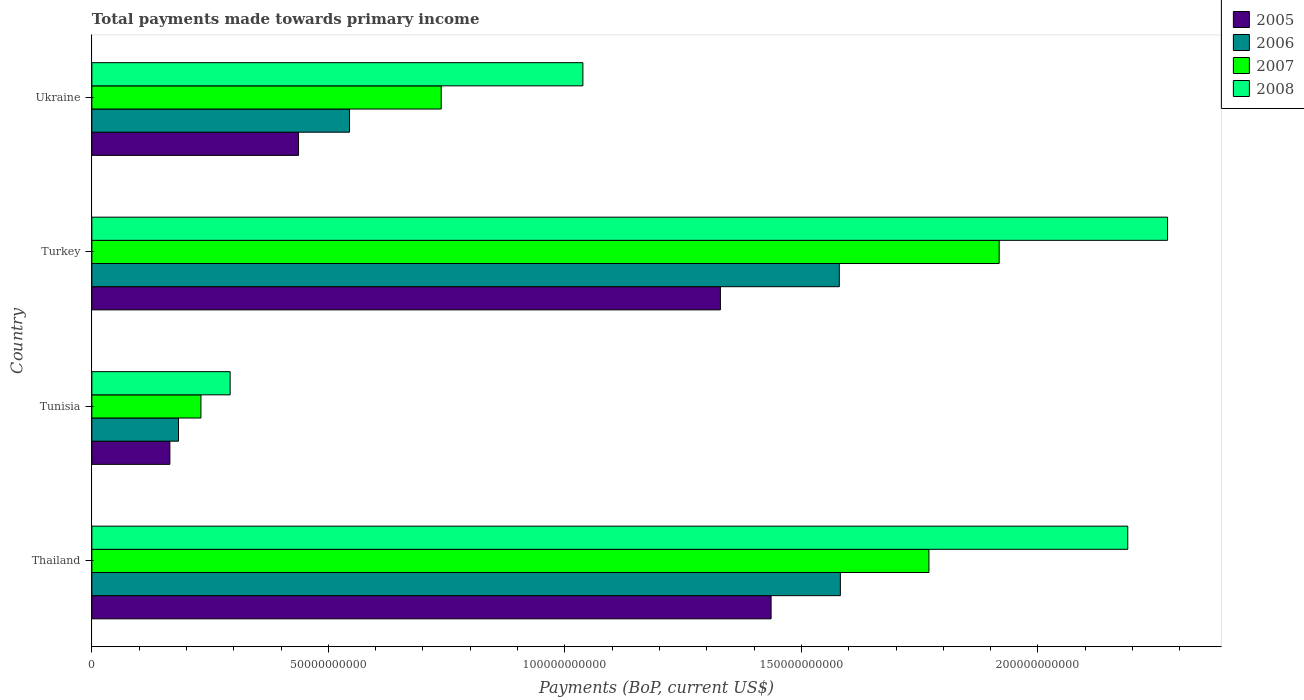How many different coloured bars are there?
Your response must be concise. 4. Are the number of bars on each tick of the Y-axis equal?
Your response must be concise. Yes. How many bars are there on the 2nd tick from the top?
Your response must be concise. 4. What is the label of the 4th group of bars from the top?
Your answer should be compact. Thailand. What is the total payments made towards primary income in 2005 in Turkey?
Provide a succinct answer. 1.33e+11. Across all countries, what is the maximum total payments made towards primary income in 2006?
Your answer should be very brief. 1.58e+11. Across all countries, what is the minimum total payments made towards primary income in 2007?
Give a very brief answer. 2.31e+1. In which country was the total payments made towards primary income in 2008 maximum?
Offer a very short reply. Turkey. In which country was the total payments made towards primary income in 2005 minimum?
Your answer should be compact. Tunisia. What is the total total payments made towards primary income in 2007 in the graph?
Your response must be concise. 4.66e+11. What is the difference between the total payments made towards primary income in 2006 in Tunisia and that in Turkey?
Provide a short and direct response. -1.40e+11. What is the difference between the total payments made towards primary income in 2008 in Ukraine and the total payments made towards primary income in 2006 in Thailand?
Give a very brief answer. -5.44e+1. What is the average total payments made towards primary income in 2005 per country?
Provide a short and direct response. 8.42e+1. What is the difference between the total payments made towards primary income in 2007 and total payments made towards primary income in 2006 in Ukraine?
Ensure brevity in your answer.  1.94e+1. In how many countries, is the total payments made towards primary income in 2006 greater than 110000000000 US$?
Make the answer very short. 2. What is the ratio of the total payments made towards primary income in 2006 in Thailand to that in Tunisia?
Offer a very short reply. 8.64. Is the total payments made towards primary income in 2008 in Tunisia less than that in Ukraine?
Offer a very short reply. Yes. What is the difference between the highest and the second highest total payments made towards primary income in 2007?
Make the answer very short. 1.48e+1. What is the difference between the highest and the lowest total payments made towards primary income in 2008?
Provide a succinct answer. 1.98e+11. In how many countries, is the total payments made towards primary income in 2008 greater than the average total payments made towards primary income in 2008 taken over all countries?
Provide a short and direct response. 2. Is it the case that in every country, the sum of the total payments made towards primary income in 2006 and total payments made towards primary income in 2005 is greater than the sum of total payments made towards primary income in 2007 and total payments made towards primary income in 2008?
Ensure brevity in your answer.  No. What does the 3rd bar from the top in Thailand represents?
Give a very brief answer. 2006. Is it the case that in every country, the sum of the total payments made towards primary income in 2007 and total payments made towards primary income in 2005 is greater than the total payments made towards primary income in 2006?
Make the answer very short. Yes. How many countries are there in the graph?
Provide a succinct answer. 4. Are the values on the major ticks of X-axis written in scientific E-notation?
Ensure brevity in your answer.  No. Does the graph contain any zero values?
Keep it short and to the point. No. How many legend labels are there?
Your answer should be compact. 4. How are the legend labels stacked?
Keep it short and to the point. Vertical. What is the title of the graph?
Offer a terse response. Total payments made towards primary income. What is the label or title of the X-axis?
Your answer should be very brief. Payments (BoP, current US$). What is the Payments (BoP, current US$) in 2005 in Thailand?
Offer a very short reply. 1.44e+11. What is the Payments (BoP, current US$) in 2006 in Thailand?
Offer a very short reply. 1.58e+11. What is the Payments (BoP, current US$) in 2007 in Thailand?
Give a very brief answer. 1.77e+11. What is the Payments (BoP, current US$) of 2008 in Thailand?
Keep it short and to the point. 2.19e+11. What is the Payments (BoP, current US$) of 2005 in Tunisia?
Keep it short and to the point. 1.65e+1. What is the Payments (BoP, current US$) of 2006 in Tunisia?
Ensure brevity in your answer.  1.83e+1. What is the Payments (BoP, current US$) of 2007 in Tunisia?
Keep it short and to the point. 2.31e+1. What is the Payments (BoP, current US$) in 2008 in Tunisia?
Provide a short and direct response. 2.92e+1. What is the Payments (BoP, current US$) of 2005 in Turkey?
Keep it short and to the point. 1.33e+11. What is the Payments (BoP, current US$) in 2006 in Turkey?
Your answer should be very brief. 1.58e+11. What is the Payments (BoP, current US$) of 2007 in Turkey?
Provide a short and direct response. 1.92e+11. What is the Payments (BoP, current US$) in 2008 in Turkey?
Provide a succinct answer. 2.27e+11. What is the Payments (BoP, current US$) in 2005 in Ukraine?
Provide a short and direct response. 4.37e+1. What is the Payments (BoP, current US$) in 2006 in Ukraine?
Provide a succinct answer. 5.45e+1. What is the Payments (BoP, current US$) of 2007 in Ukraine?
Your response must be concise. 7.39e+1. What is the Payments (BoP, current US$) of 2008 in Ukraine?
Your answer should be compact. 1.04e+11. Across all countries, what is the maximum Payments (BoP, current US$) in 2005?
Give a very brief answer. 1.44e+11. Across all countries, what is the maximum Payments (BoP, current US$) in 2006?
Your response must be concise. 1.58e+11. Across all countries, what is the maximum Payments (BoP, current US$) of 2007?
Provide a succinct answer. 1.92e+11. Across all countries, what is the maximum Payments (BoP, current US$) of 2008?
Provide a short and direct response. 2.27e+11. Across all countries, what is the minimum Payments (BoP, current US$) in 2005?
Make the answer very short. 1.65e+1. Across all countries, what is the minimum Payments (BoP, current US$) of 2006?
Keep it short and to the point. 1.83e+1. Across all countries, what is the minimum Payments (BoP, current US$) in 2007?
Give a very brief answer. 2.31e+1. Across all countries, what is the minimum Payments (BoP, current US$) of 2008?
Provide a succinct answer. 2.92e+1. What is the total Payments (BoP, current US$) in 2005 in the graph?
Make the answer very short. 3.37e+11. What is the total Payments (BoP, current US$) in 2006 in the graph?
Your answer should be very brief. 3.89e+11. What is the total Payments (BoP, current US$) of 2007 in the graph?
Your answer should be compact. 4.66e+11. What is the total Payments (BoP, current US$) in 2008 in the graph?
Your answer should be very brief. 5.79e+11. What is the difference between the Payments (BoP, current US$) of 2005 in Thailand and that in Tunisia?
Your response must be concise. 1.27e+11. What is the difference between the Payments (BoP, current US$) of 2006 in Thailand and that in Tunisia?
Keep it short and to the point. 1.40e+11. What is the difference between the Payments (BoP, current US$) in 2007 in Thailand and that in Tunisia?
Provide a short and direct response. 1.54e+11. What is the difference between the Payments (BoP, current US$) of 2008 in Thailand and that in Tunisia?
Make the answer very short. 1.90e+11. What is the difference between the Payments (BoP, current US$) in 2005 in Thailand and that in Turkey?
Offer a very short reply. 1.07e+1. What is the difference between the Payments (BoP, current US$) in 2006 in Thailand and that in Turkey?
Keep it short and to the point. 2.24e+08. What is the difference between the Payments (BoP, current US$) in 2007 in Thailand and that in Turkey?
Ensure brevity in your answer.  -1.48e+1. What is the difference between the Payments (BoP, current US$) in 2008 in Thailand and that in Turkey?
Your answer should be very brief. -8.42e+09. What is the difference between the Payments (BoP, current US$) in 2005 in Thailand and that in Ukraine?
Offer a very short reply. 9.99e+1. What is the difference between the Payments (BoP, current US$) in 2006 in Thailand and that in Ukraine?
Provide a short and direct response. 1.04e+11. What is the difference between the Payments (BoP, current US$) in 2007 in Thailand and that in Ukraine?
Give a very brief answer. 1.03e+11. What is the difference between the Payments (BoP, current US$) of 2008 in Thailand and that in Ukraine?
Make the answer very short. 1.15e+11. What is the difference between the Payments (BoP, current US$) in 2005 in Tunisia and that in Turkey?
Give a very brief answer. -1.16e+11. What is the difference between the Payments (BoP, current US$) in 2006 in Tunisia and that in Turkey?
Your answer should be compact. -1.40e+11. What is the difference between the Payments (BoP, current US$) in 2007 in Tunisia and that in Turkey?
Offer a very short reply. -1.69e+11. What is the difference between the Payments (BoP, current US$) of 2008 in Tunisia and that in Turkey?
Your response must be concise. -1.98e+11. What is the difference between the Payments (BoP, current US$) in 2005 in Tunisia and that in Ukraine?
Give a very brief answer. -2.72e+1. What is the difference between the Payments (BoP, current US$) of 2006 in Tunisia and that in Ukraine?
Offer a very short reply. -3.62e+1. What is the difference between the Payments (BoP, current US$) in 2007 in Tunisia and that in Ukraine?
Ensure brevity in your answer.  -5.08e+1. What is the difference between the Payments (BoP, current US$) of 2008 in Tunisia and that in Ukraine?
Make the answer very short. -7.46e+1. What is the difference between the Payments (BoP, current US$) of 2005 in Turkey and that in Ukraine?
Keep it short and to the point. 8.92e+1. What is the difference between the Payments (BoP, current US$) in 2006 in Turkey and that in Ukraine?
Make the answer very short. 1.04e+11. What is the difference between the Payments (BoP, current US$) of 2007 in Turkey and that in Ukraine?
Ensure brevity in your answer.  1.18e+11. What is the difference between the Payments (BoP, current US$) of 2008 in Turkey and that in Ukraine?
Make the answer very short. 1.24e+11. What is the difference between the Payments (BoP, current US$) of 2005 in Thailand and the Payments (BoP, current US$) of 2006 in Tunisia?
Your answer should be compact. 1.25e+11. What is the difference between the Payments (BoP, current US$) of 2005 in Thailand and the Payments (BoP, current US$) of 2007 in Tunisia?
Provide a succinct answer. 1.21e+11. What is the difference between the Payments (BoP, current US$) of 2005 in Thailand and the Payments (BoP, current US$) of 2008 in Tunisia?
Your answer should be very brief. 1.14e+11. What is the difference between the Payments (BoP, current US$) of 2006 in Thailand and the Payments (BoP, current US$) of 2007 in Tunisia?
Ensure brevity in your answer.  1.35e+11. What is the difference between the Payments (BoP, current US$) in 2006 in Thailand and the Payments (BoP, current US$) in 2008 in Tunisia?
Offer a terse response. 1.29e+11. What is the difference between the Payments (BoP, current US$) of 2007 in Thailand and the Payments (BoP, current US$) of 2008 in Tunisia?
Ensure brevity in your answer.  1.48e+11. What is the difference between the Payments (BoP, current US$) of 2005 in Thailand and the Payments (BoP, current US$) of 2006 in Turkey?
Keep it short and to the point. -1.44e+1. What is the difference between the Payments (BoP, current US$) in 2005 in Thailand and the Payments (BoP, current US$) in 2007 in Turkey?
Provide a succinct answer. -4.82e+1. What is the difference between the Payments (BoP, current US$) of 2005 in Thailand and the Payments (BoP, current US$) of 2008 in Turkey?
Your answer should be compact. -8.38e+1. What is the difference between the Payments (BoP, current US$) in 2006 in Thailand and the Payments (BoP, current US$) in 2007 in Turkey?
Keep it short and to the point. -3.36e+1. What is the difference between the Payments (BoP, current US$) in 2006 in Thailand and the Payments (BoP, current US$) in 2008 in Turkey?
Ensure brevity in your answer.  -6.92e+1. What is the difference between the Payments (BoP, current US$) in 2007 in Thailand and the Payments (BoP, current US$) in 2008 in Turkey?
Keep it short and to the point. -5.04e+1. What is the difference between the Payments (BoP, current US$) in 2005 in Thailand and the Payments (BoP, current US$) in 2006 in Ukraine?
Your answer should be very brief. 8.91e+1. What is the difference between the Payments (BoP, current US$) in 2005 in Thailand and the Payments (BoP, current US$) in 2007 in Ukraine?
Make the answer very short. 6.97e+1. What is the difference between the Payments (BoP, current US$) of 2005 in Thailand and the Payments (BoP, current US$) of 2008 in Ukraine?
Offer a terse response. 3.98e+1. What is the difference between the Payments (BoP, current US$) in 2006 in Thailand and the Payments (BoP, current US$) in 2007 in Ukraine?
Your answer should be compact. 8.44e+1. What is the difference between the Payments (BoP, current US$) in 2006 in Thailand and the Payments (BoP, current US$) in 2008 in Ukraine?
Offer a terse response. 5.44e+1. What is the difference between the Payments (BoP, current US$) of 2007 in Thailand and the Payments (BoP, current US$) of 2008 in Ukraine?
Keep it short and to the point. 7.32e+1. What is the difference between the Payments (BoP, current US$) of 2005 in Tunisia and the Payments (BoP, current US$) of 2006 in Turkey?
Your answer should be very brief. -1.42e+11. What is the difference between the Payments (BoP, current US$) of 2005 in Tunisia and the Payments (BoP, current US$) of 2007 in Turkey?
Offer a terse response. -1.75e+11. What is the difference between the Payments (BoP, current US$) in 2005 in Tunisia and the Payments (BoP, current US$) in 2008 in Turkey?
Offer a very short reply. -2.11e+11. What is the difference between the Payments (BoP, current US$) of 2006 in Tunisia and the Payments (BoP, current US$) of 2007 in Turkey?
Your response must be concise. -1.73e+11. What is the difference between the Payments (BoP, current US$) of 2006 in Tunisia and the Payments (BoP, current US$) of 2008 in Turkey?
Your answer should be compact. -2.09e+11. What is the difference between the Payments (BoP, current US$) of 2007 in Tunisia and the Payments (BoP, current US$) of 2008 in Turkey?
Keep it short and to the point. -2.04e+11. What is the difference between the Payments (BoP, current US$) in 2005 in Tunisia and the Payments (BoP, current US$) in 2006 in Ukraine?
Provide a short and direct response. -3.80e+1. What is the difference between the Payments (BoP, current US$) in 2005 in Tunisia and the Payments (BoP, current US$) in 2007 in Ukraine?
Your answer should be compact. -5.74e+1. What is the difference between the Payments (BoP, current US$) in 2005 in Tunisia and the Payments (BoP, current US$) in 2008 in Ukraine?
Provide a succinct answer. -8.73e+1. What is the difference between the Payments (BoP, current US$) in 2006 in Tunisia and the Payments (BoP, current US$) in 2007 in Ukraine?
Provide a short and direct response. -5.55e+1. What is the difference between the Payments (BoP, current US$) of 2006 in Tunisia and the Payments (BoP, current US$) of 2008 in Ukraine?
Ensure brevity in your answer.  -8.55e+1. What is the difference between the Payments (BoP, current US$) in 2007 in Tunisia and the Payments (BoP, current US$) in 2008 in Ukraine?
Offer a terse response. -8.07e+1. What is the difference between the Payments (BoP, current US$) of 2005 in Turkey and the Payments (BoP, current US$) of 2006 in Ukraine?
Give a very brief answer. 7.84e+1. What is the difference between the Payments (BoP, current US$) in 2005 in Turkey and the Payments (BoP, current US$) in 2007 in Ukraine?
Provide a succinct answer. 5.90e+1. What is the difference between the Payments (BoP, current US$) of 2005 in Turkey and the Payments (BoP, current US$) of 2008 in Ukraine?
Your answer should be compact. 2.91e+1. What is the difference between the Payments (BoP, current US$) in 2006 in Turkey and the Payments (BoP, current US$) in 2007 in Ukraine?
Give a very brief answer. 8.42e+1. What is the difference between the Payments (BoP, current US$) of 2006 in Turkey and the Payments (BoP, current US$) of 2008 in Ukraine?
Offer a terse response. 5.42e+1. What is the difference between the Payments (BoP, current US$) of 2007 in Turkey and the Payments (BoP, current US$) of 2008 in Ukraine?
Offer a very short reply. 8.80e+1. What is the average Payments (BoP, current US$) in 2005 per country?
Ensure brevity in your answer.  8.42e+1. What is the average Payments (BoP, current US$) of 2006 per country?
Provide a short and direct response. 9.73e+1. What is the average Payments (BoP, current US$) of 2007 per country?
Keep it short and to the point. 1.16e+11. What is the average Payments (BoP, current US$) in 2008 per country?
Offer a terse response. 1.45e+11. What is the difference between the Payments (BoP, current US$) in 2005 and Payments (BoP, current US$) in 2006 in Thailand?
Make the answer very short. -1.46e+1. What is the difference between the Payments (BoP, current US$) in 2005 and Payments (BoP, current US$) in 2007 in Thailand?
Your answer should be very brief. -3.34e+1. What is the difference between the Payments (BoP, current US$) of 2005 and Payments (BoP, current US$) of 2008 in Thailand?
Keep it short and to the point. -7.54e+1. What is the difference between the Payments (BoP, current US$) in 2006 and Payments (BoP, current US$) in 2007 in Thailand?
Offer a terse response. -1.87e+1. What is the difference between the Payments (BoP, current US$) of 2006 and Payments (BoP, current US$) of 2008 in Thailand?
Make the answer very short. -6.08e+1. What is the difference between the Payments (BoP, current US$) in 2007 and Payments (BoP, current US$) in 2008 in Thailand?
Your answer should be very brief. -4.20e+1. What is the difference between the Payments (BoP, current US$) in 2005 and Payments (BoP, current US$) in 2006 in Tunisia?
Provide a short and direct response. -1.82e+09. What is the difference between the Payments (BoP, current US$) of 2005 and Payments (BoP, current US$) of 2007 in Tunisia?
Provide a succinct answer. -6.57e+09. What is the difference between the Payments (BoP, current US$) in 2005 and Payments (BoP, current US$) in 2008 in Tunisia?
Your response must be concise. -1.27e+1. What is the difference between the Payments (BoP, current US$) of 2006 and Payments (BoP, current US$) of 2007 in Tunisia?
Your answer should be compact. -4.74e+09. What is the difference between the Payments (BoP, current US$) of 2006 and Payments (BoP, current US$) of 2008 in Tunisia?
Your answer should be compact. -1.09e+1. What is the difference between the Payments (BoP, current US$) in 2007 and Payments (BoP, current US$) in 2008 in Tunisia?
Provide a succinct answer. -6.17e+09. What is the difference between the Payments (BoP, current US$) in 2005 and Payments (BoP, current US$) in 2006 in Turkey?
Your answer should be compact. -2.51e+1. What is the difference between the Payments (BoP, current US$) in 2005 and Payments (BoP, current US$) in 2007 in Turkey?
Offer a terse response. -5.89e+1. What is the difference between the Payments (BoP, current US$) of 2005 and Payments (BoP, current US$) of 2008 in Turkey?
Offer a very short reply. -9.45e+1. What is the difference between the Payments (BoP, current US$) of 2006 and Payments (BoP, current US$) of 2007 in Turkey?
Ensure brevity in your answer.  -3.38e+1. What is the difference between the Payments (BoP, current US$) of 2006 and Payments (BoP, current US$) of 2008 in Turkey?
Give a very brief answer. -6.94e+1. What is the difference between the Payments (BoP, current US$) of 2007 and Payments (BoP, current US$) of 2008 in Turkey?
Give a very brief answer. -3.56e+1. What is the difference between the Payments (BoP, current US$) in 2005 and Payments (BoP, current US$) in 2006 in Ukraine?
Offer a very short reply. -1.08e+1. What is the difference between the Payments (BoP, current US$) in 2005 and Payments (BoP, current US$) in 2007 in Ukraine?
Provide a short and direct response. -3.02e+1. What is the difference between the Payments (BoP, current US$) in 2005 and Payments (BoP, current US$) in 2008 in Ukraine?
Offer a terse response. -6.01e+1. What is the difference between the Payments (BoP, current US$) of 2006 and Payments (BoP, current US$) of 2007 in Ukraine?
Provide a succinct answer. -1.94e+1. What is the difference between the Payments (BoP, current US$) in 2006 and Payments (BoP, current US$) in 2008 in Ukraine?
Offer a very short reply. -4.93e+1. What is the difference between the Payments (BoP, current US$) of 2007 and Payments (BoP, current US$) of 2008 in Ukraine?
Give a very brief answer. -2.99e+1. What is the ratio of the Payments (BoP, current US$) of 2005 in Thailand to that in Tunisia?
Offer a very short reply. 8.7. What is the ratio of the Payments (BoP, current US$) in 2006 in Thailand to that in Tunisia?
Ensure brevity in your answer.  8.64. What is the ratio of the Payments (BoP, current US$) of 2007 in Thailand to that in Tunisia?
Provide a short and direct response. 7.67. What is the ratio of the Payments (BoP, current US$) of 2008 in Thailand to that in Tunisia?
Provide a succinct answer. 7.49. What is the ratio of the Payments (BoP, current US$) in 2005 in Thailand to that in Turkey?
Ensure brevity in your answer.  1.08. What is the ratio of the Payments (BoP, current US$) in 2006 in Thailand to that in Turkey?
Provide a short and direct response. 1. What is the ratio of the Payments (BoP, current US$) of 2007 in Thailand to that in Turkey?
Provide a short and direct response. 0.92. What is the ratio of the Payments (BoP, current US$) of 2008 in Thailand to that in Turkey?
Give a very brief answer. 0.96. What is the ratio of the Payments (BoP, current US$) of 2005 in Thailand to that in Ukraine?
Offer a very short reply. 3.29. What is the ratio of the Payments (BoP, current US$) of 2006 in Thailand to that in Ukraine?
Your response must be concise. 2.9. What is the ratio of the Payments (BoP, current US$) in 2007 in Thailand to that in Ukraine?
Your answer should be compact. 2.4. What is the ratio of the Payments (BoP, current US$) of 2008 in Thailand to that in Ukraine?
Offer a terse response. 2.11. What is the ratio of the Payments (BoP, current US$) in 2005 in Tunisia to that in Turkey?
Make the answer very short. 0.12. What is the ratio of the Payments (BoP, current US$) of 2006 in Tunisia to that in Turkey?
Offer a terse response. 0.12. What is the ratio of the Payments (BoP, current US$) in 2007 in Tunisia to that in Turkey?
Your answer should be compact. 0.12. What is the ratio of the Payments (BoP, current US$) of 2008 in Tunisia to that in Turkey?
Your answer should be very brief. 0.13. What is the ratio of the Payments (BoP, current US$) in 2005 in Tunisia to that in Ukraine?
Offer a very short reply. 0.38. What is the ratio of the Payments (BoP, current US$) in 2006 in Tunisia to that in Ukraine?
Offer a very short reply. 0.34. What is the ratio of the Payments (BoP, current US$) of 2007 in Tunisia to that in Ukraine?
Your answer should be compact. 0.31. What is the ratio of the Payments (BoP, current US$) of 2008 in Tunisia to that in Ukraine?
Your answer should be very brief. 0.28. What is the ratio of the Payments (BoP, current US$) in 2005 in Turkey to that in Ukraine?
Make the answer very short. 3.04. What is the ratio of the Payments (BoP, current US$) of 2006 in Turkey to that in Ukraine?
Make the answer very short. 2.9. What is the ratio of the Payments (BoP, current US$) in 2007 in Turkey to that in Ukraine?
Ensure brevity in your answer.  2.6. What is the ratio of the Payments (BoP, current US$) in 2008 in Turkey to that in Ukraine?
Give a very brief answer. 2.19. What is the difference between the highest and the second highest Payments (BoP, current US$) of 2005?
Your response must be concise. 1.07e+1. What is the difference between the highest and the second highest Payments (BoP, current US$) in 2006?
Give a very brief answer. 2.24e+08. What is the difference between the highest and the second highest Payments (BoP, current US$) of 2007?
Your response must be concise. 1.48e+1. What is the difference between the highest and the second highest Payments (BoP, current US$) of 2008?
Your answer should be compact. 8.42e+09. What is the difference between the highest and the lowest Payments (BoP, current US$) of 2005?
Offer a very short reply. 1.27e+11. What is the difference between the highest and the lowest Payments (BoP, current US$) in 2006?
Provide a short and direct response. 1.40e+11. What is the difference between the highest and the lowest Payments (BoP, current US$) in 2007?
Keep it short and to the point. 1.69e+11. What is the difference between the highest and the lowest Payments (BoP, current US$) in 2008?
Ensure brevity in your answer.  1.98e+11. 